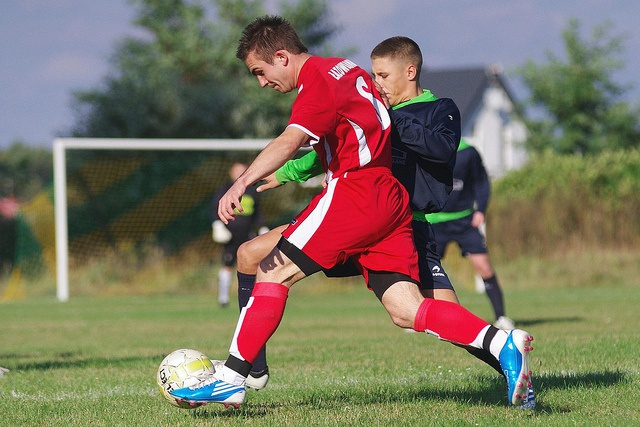Describe the objects in this image and their specific colors. I can see people in darkgray, brown, white, and black tones, people in darkgray, black, and tan tones, people in darkgray, black, gray, and lightpink tones, sports ball in darkgray, ivory, khaki, and olive tones, and people in darkgray, black, olive, and gray tones in this image. 